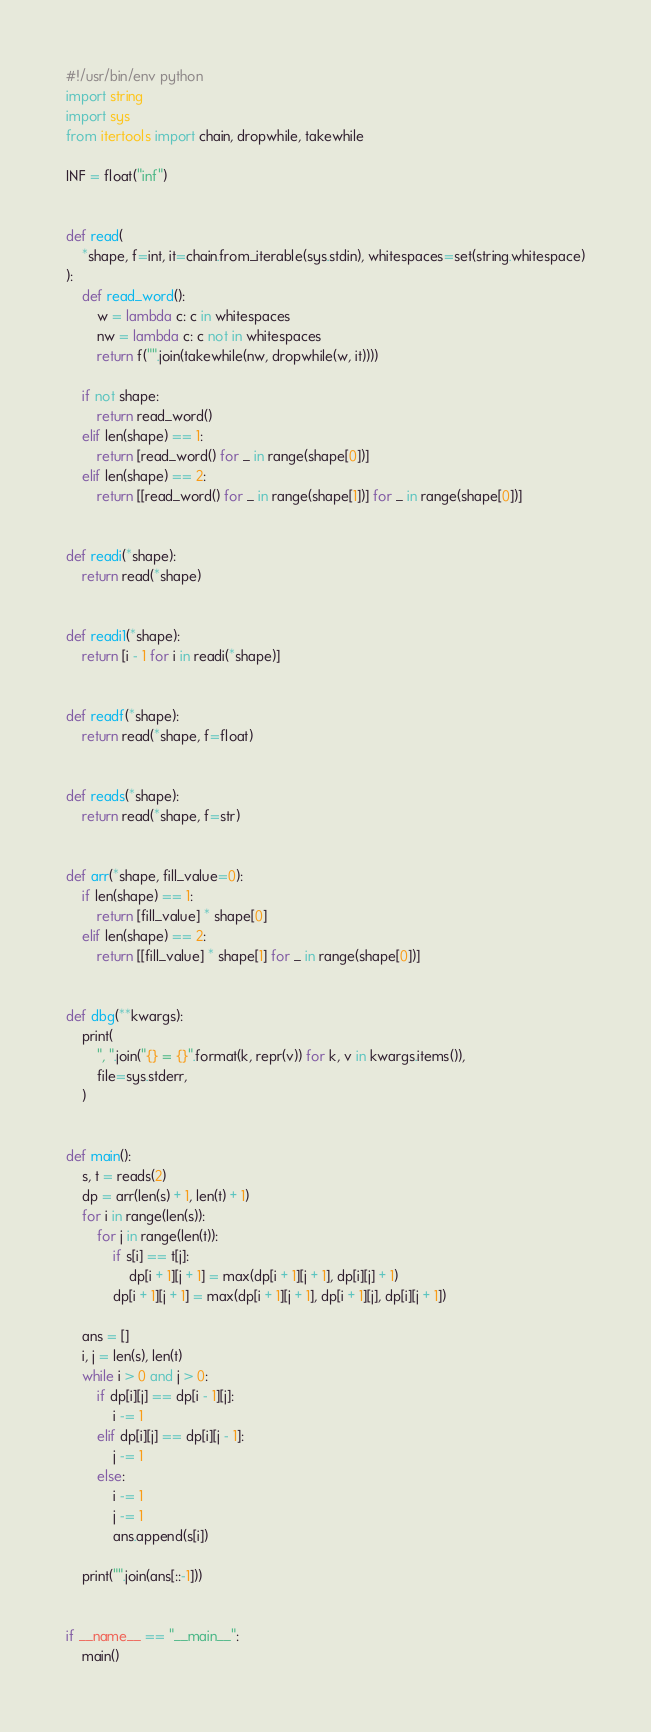<code> <loc_0><loc_0><loc_500><loc_500><_Python_>#!/usr/bin/env python
import string
import sys
from itertools import chain, dropwhile, takewhile

INF = float("inf")


def read(
    *shape, f=int, it=chain.from_iterable(sys.stdin), whitespaces=set(string.whitespace)
):
    def read_word():
        w = lambda c: c in whitespaces
        nw = lambda c: c not in whitespaces
        return f("".join(takewhile(nw, dropwhile(w, it))))

    if not shape:
        return read_word()
    elif len(shape) == 1:
        return [read_word() for _ in range(shape[0])]
    elif len(shape) == 2:
        return [[read_word() for _ in range(shape[1])] for _ in range(shape[0])]


def readi(*shape):
    return read(*shape)


def readi1(*shape):
    return [i - 1 for i in readi(*shape)]


def readf(*shape):
    return read(*shape, f=float)


def reads(*shape):
    return read(*shape, f=str)


def arr(*shape, fill_value=0):
    if len(shape) == 1:
        return [fill_value] * shape[0]
    elif len(shape) == 2:
        return [[fill_value] * shape[1] for _ in range(shape[0])]


def dbg(**kwargs):
    print(
        ", ".join("{} = {}".format(k, repr(v)) for k, v in kwargs.items()),
        file=sys.stderr,
    )


def main():
    s, t = reads(2)
    dp = arr(len(s) + 1, len(t) + 1)
    for i in range(len(s)):
        for j in range(len(t)):
            if s[i] == t[j]:
                dp[i + 1][j + 1] = max(dp[i + 1][j + 1], dp[i][j] + 1)
            dp[i + 1][j + 1] = max(dp[i + 1][j + 1], dp[i + 1][j], dp[i][j + 1])

    ans = []
    i, j = len(s), len(t)
    while i > 0 and j > 0:
        if dp[i][j] == dp[i - 1][j]:
            i -= 1
        elif dp[i][j] == dp[i][j - 1]:
            j -= 1
        else:
            i -= 1
            j -= 1
            ans.append(s[i])

    print("".join(ans[::-1]))


if __name__ == "__main__":
    main()
</code> 